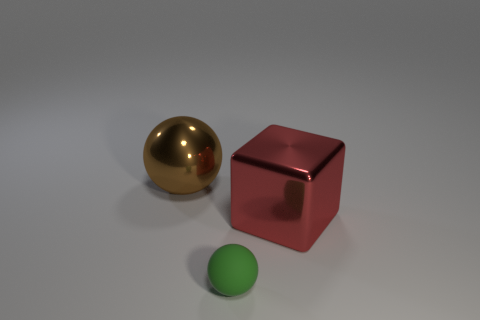There is a ball in front of the shiny object right of the large thing that is left of the tiny thing; what is its material?
Ensure brevity in your answer.  Rubber. There is a big object that is made of the same material as the large ball; what is its color?
Offer a very short reply. Red. What number of small objects are in front of the thing that is in front of the large red metallic block on the right side of the tiny green object?
Provide a succinct answer. 0. Is there anything else that has the same shape as the large red object?
Make the answer very short. No. How many things are large metallic things right of the small matte sphere or purple metallic cylinders?
Ensure brevity in your answer.  1. There is a sphere behind the small matte sphere; is its color the same as the tiny rubber ball?
Your response must be concise. No. There is a large object that is on the left side of the metal thing in front of the brown shiny sphere; what is its shape?
Provide a short and direct response. Sphere. Are there fewer tiny matte balls that are on the right side of the tiny green rubber thing than big objects that are behind the big red shiny cube?
Provide a short and direct response. Yes. The brown shiny thing that is the same shape as the rubber thing is what size?
Offer a very short reply. Large. Are there any other things that are the same size as the green rubber sphere?
Your answer should be very brief. No. 